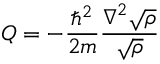Convert formula to latex. <formula><loc_0><loc_0><loc_500><loc_500>Q = - { \frac { \hbar { ^ } { 2 } } { 2 m } } { \frac { \nabla ^ { 2 } { \sqrt { \rho } } } { \sqrt { \rho } } }</formula> 